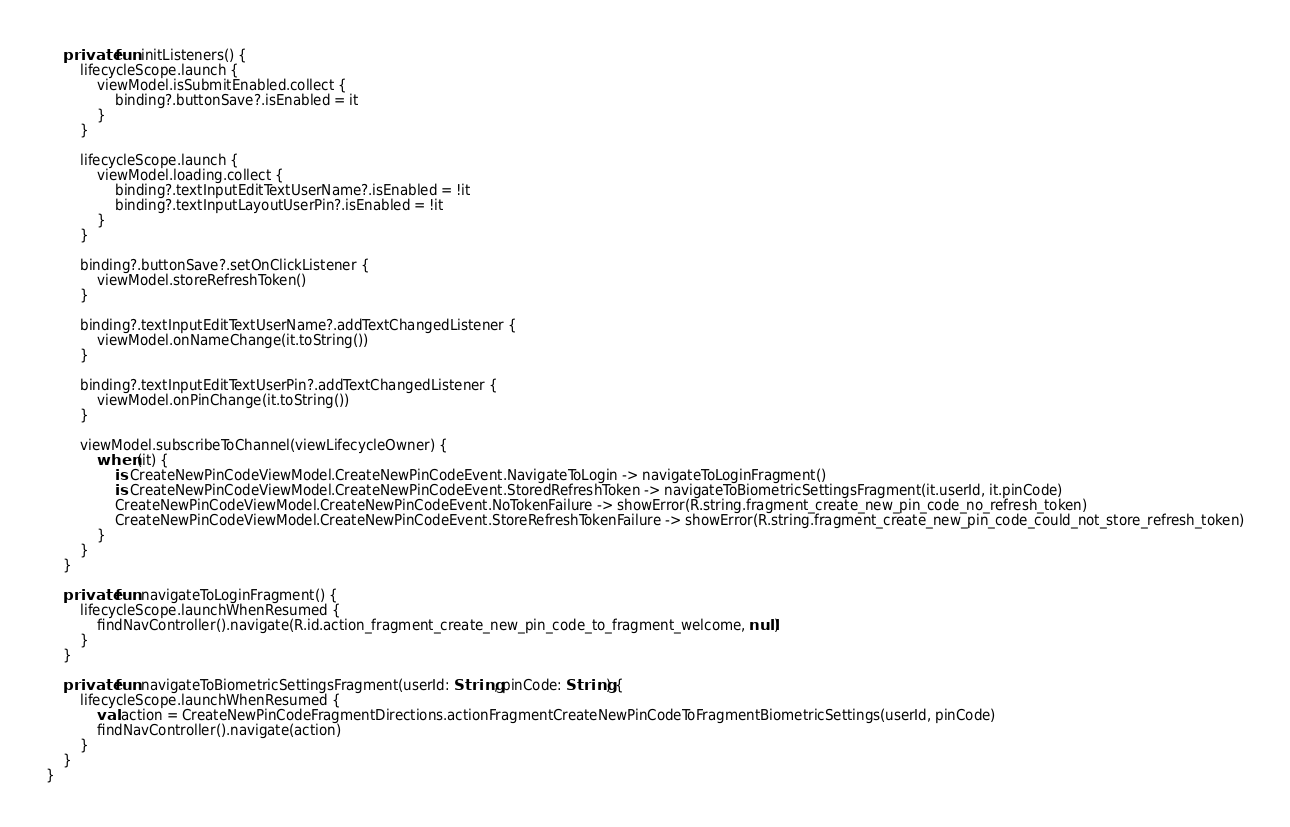<code> <loc_0><loc_0><loc_500><loc_500><_Kotlin_>
    private fun initListeners() {
        lifecycleScope.launch {
            viewModel.isSubmitEnabled.collect {
                binding?.buttonSave?.isEnabled = it
            }
        }

        lifecycleScope.launch {
            viewModel.loading.collect {
                binding?.textInputEditTextUserName?.isEnabled = !it
                binding?.textInputLayoutUserPin?.isEnabled = !it
            }
        }

        binding?.buttonSave?.setOnClickListener {
            viewModel.storeRefreshToken()
        }

        binding?.textInputEditTextUserName?.addTextChangedListener {
            viewModel.onNameChange(it.toString())
        }

        binding?.textInputEditTextUserPin?.addTextChangedListener {
            viewModel.onPinChange(it.toString())
        }

        viewModel.subscribeToChannel(viewLifecycleOwner) {
            when (it) {
                is CreateNewPinCodeViewModel.CreateNewPinCodeEvent.NavigateToLogin -> navigateToLoginFragment()
                is CreateNewPinCodeViewModel.CreateNewPinCodeEvent.StoredRefreshToken -> navigateToBiometricSettingsFragment(it.userId, it.pinCode)
                CreateNewPinCodeViewModel.CreateNewPinCodeEvent.NoTokenFailure -> showError(R.string.fragment_create_new_pin_code_no_refresh_token)
                CreateNewPinCodeViewModel.CreateNewPinCodeEvent.StoreRefreshTokenFailure -> showError(R.string.fragment_create_new_pin_code_could_not_store_refresh_token)
            }
        }
    }

    private fun navigateToLoginFragment() {
        lifecycleScope.launchWhenResumed {
            findNavController().navigate(R.id.action_fragment_create_new_pin_code_to_fragment_welcome, null)
        }
    }

    private fun navigateToBiometricSettingsFragment(userId: String, pinCode: String) {
        lifecycleScope.launchWhenResumed {
            val action = CreateNewPinCodeFragmentDirections.actionFragmentCreateNewPinCodeToFragmentBiometricSettings(userId, pinCode)
            findNavController().navigate(action)
        }
    }
}</code> 